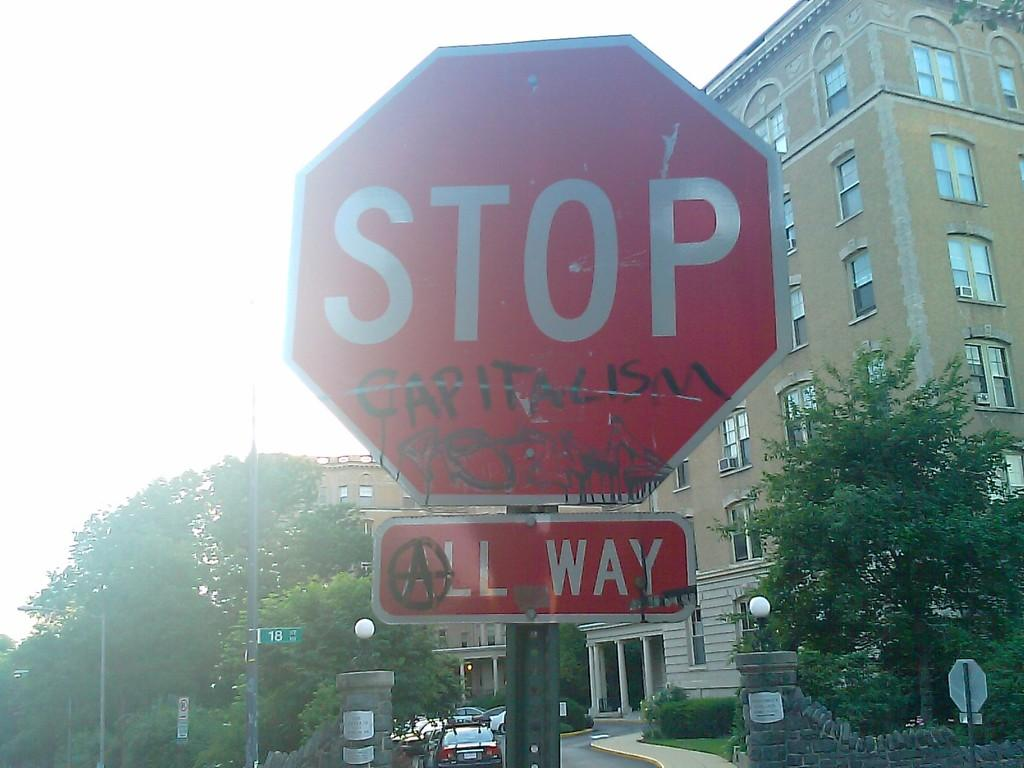<image>
Render a clear and concise summary of the photo. A red stop sign says Capitalism in graffiti letters. 